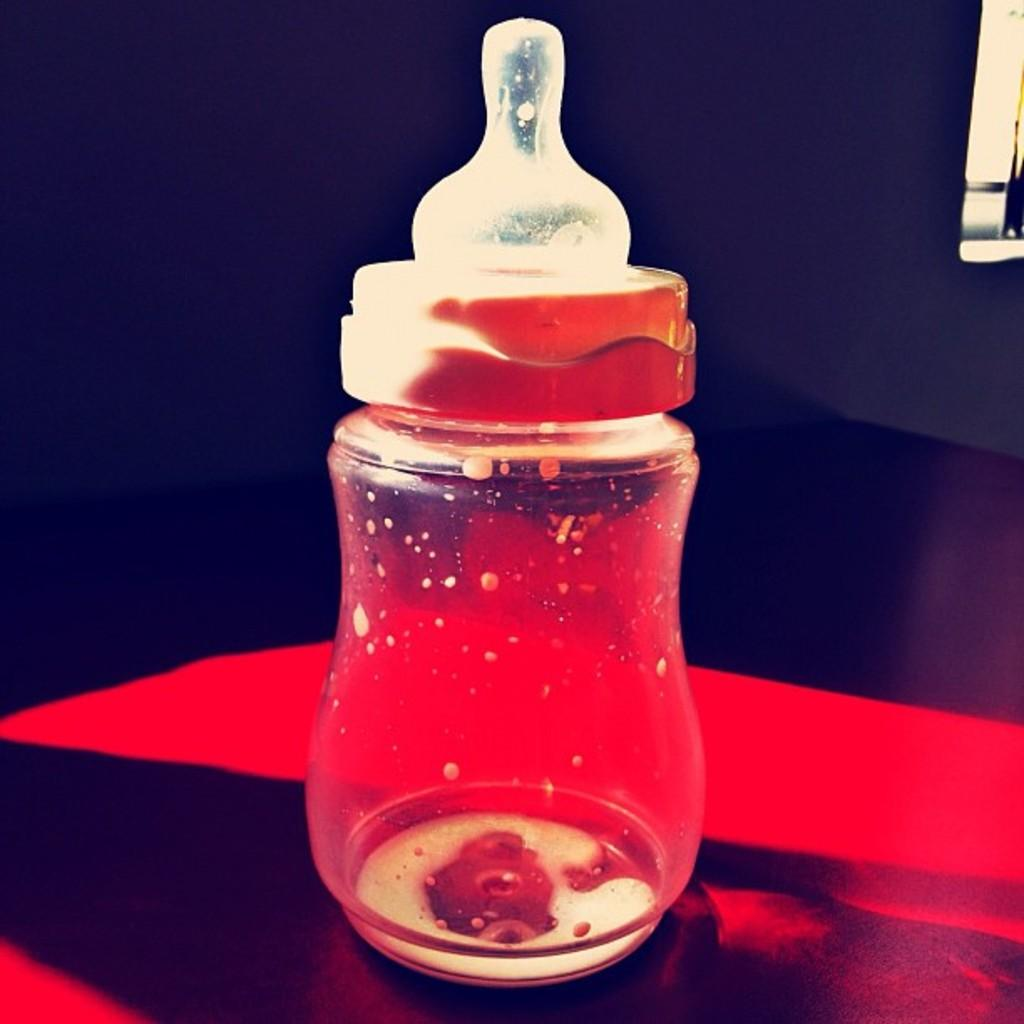What object can be seen in the image? There is a plastic bottle in the image. What feature does the plastic bottle have? The plastic bottle has a zipper. What type of leaf can be seen on the plastic bottle in the image? There is no leaf present on the plastic bottle in the image. 